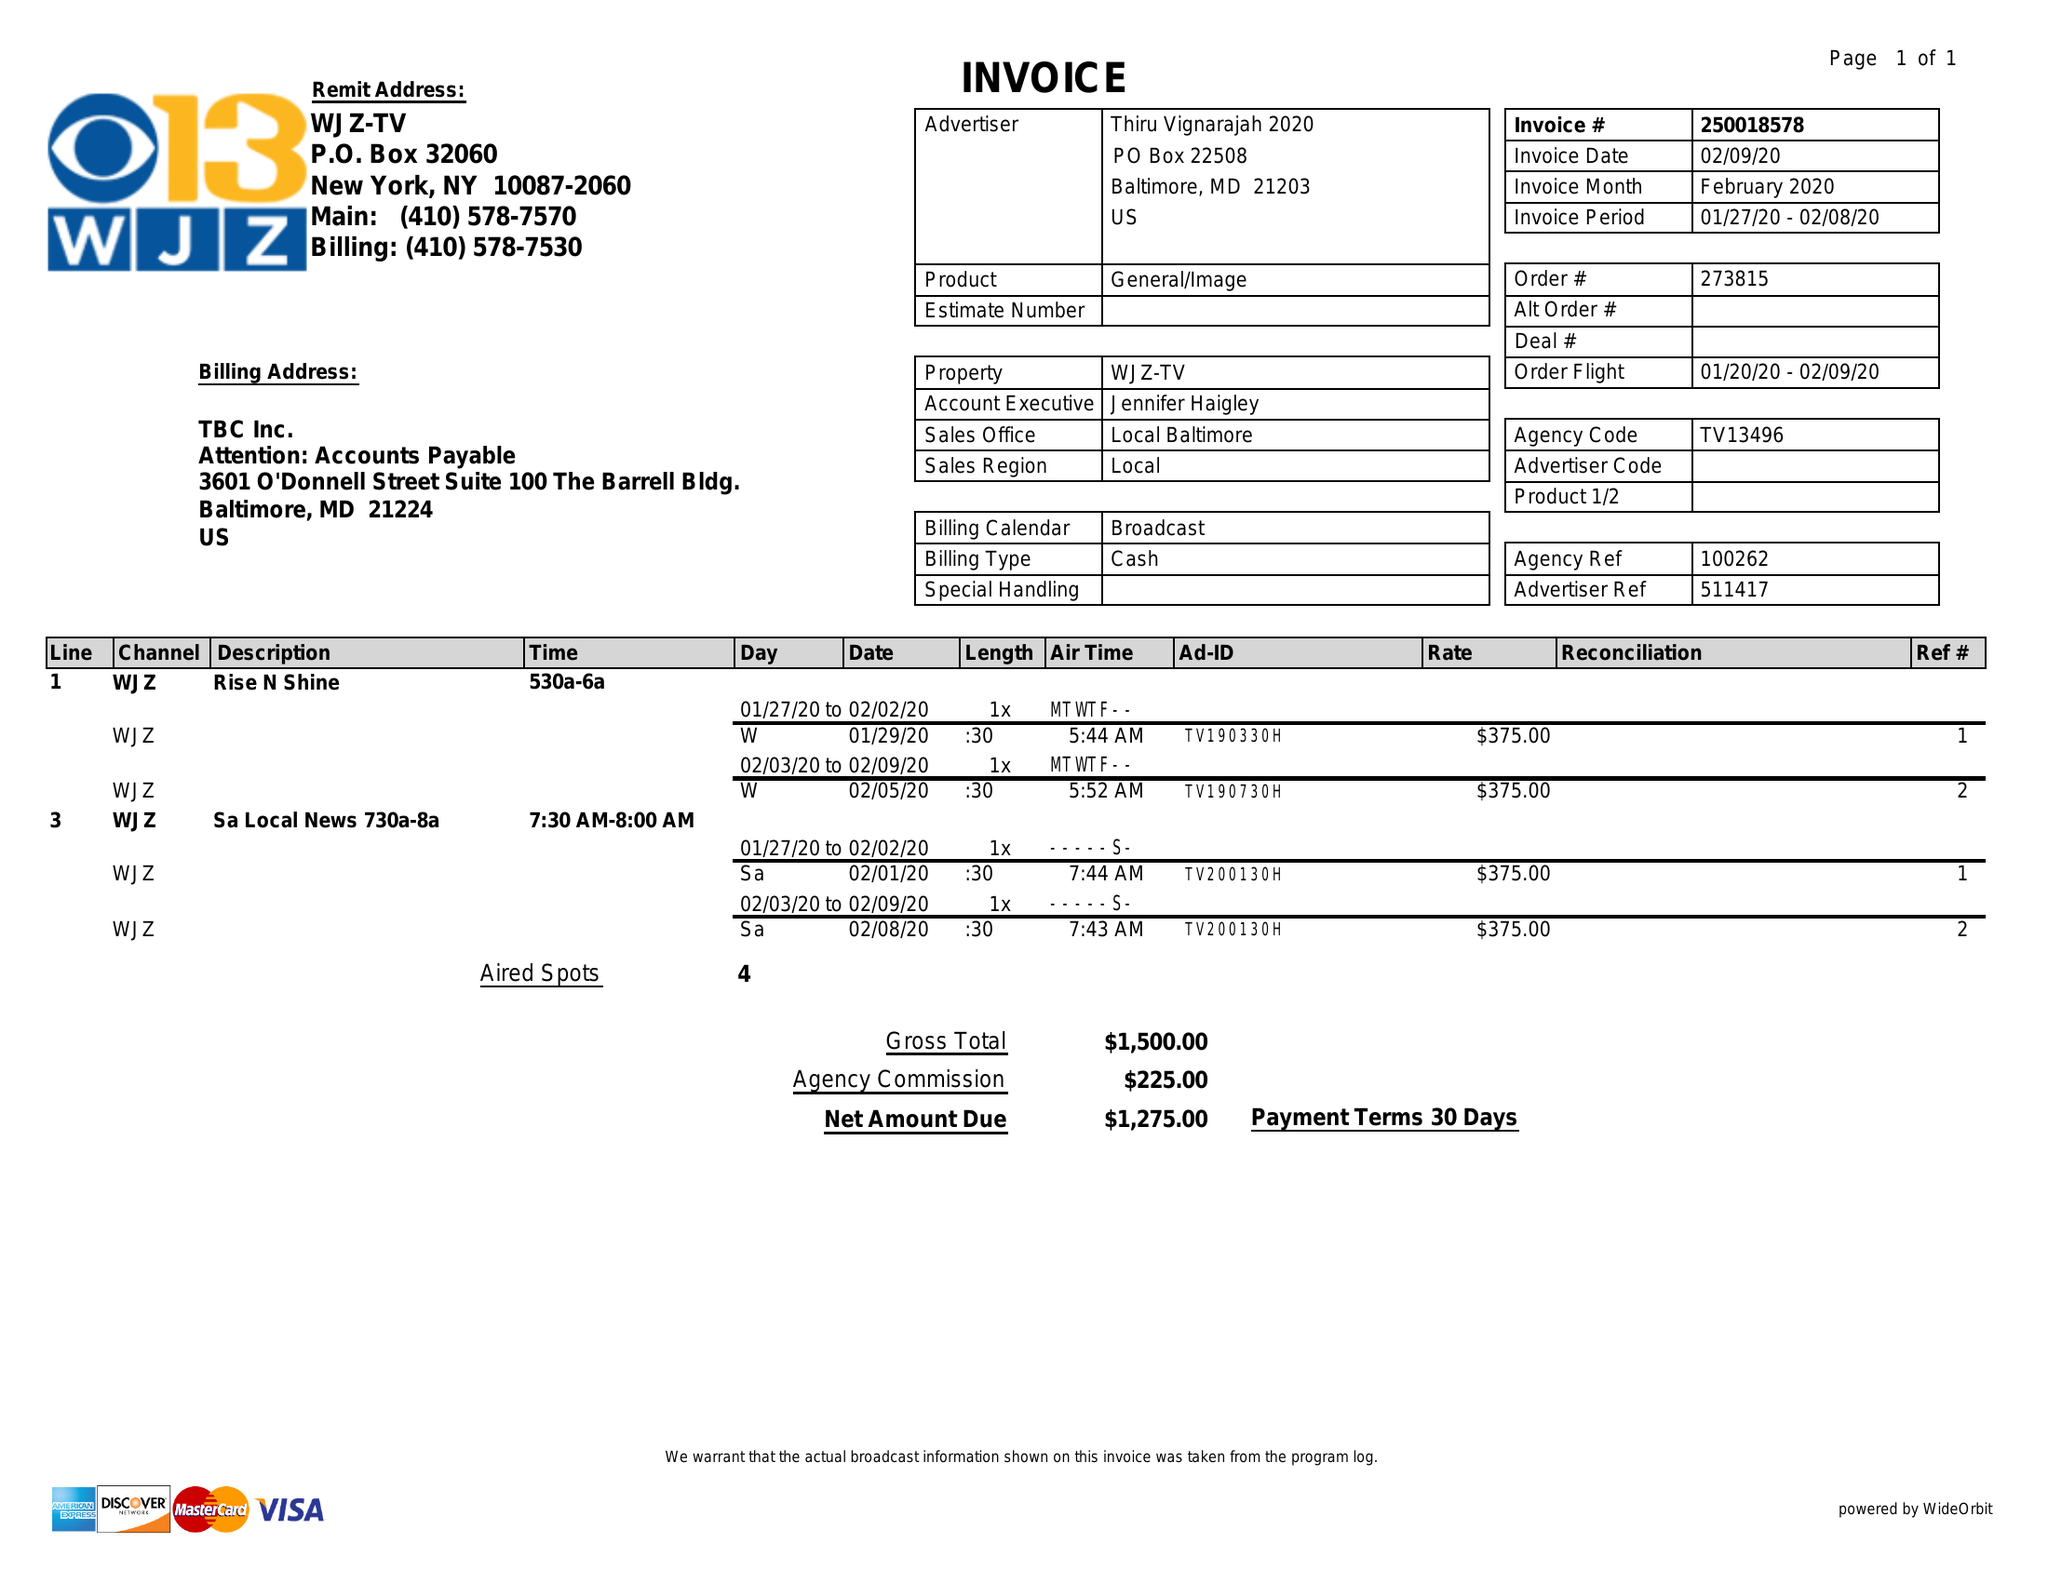What is the value for the advertiser?
Answer the question using a single word or phrase. THIRU VIGNARAJAH 2020 